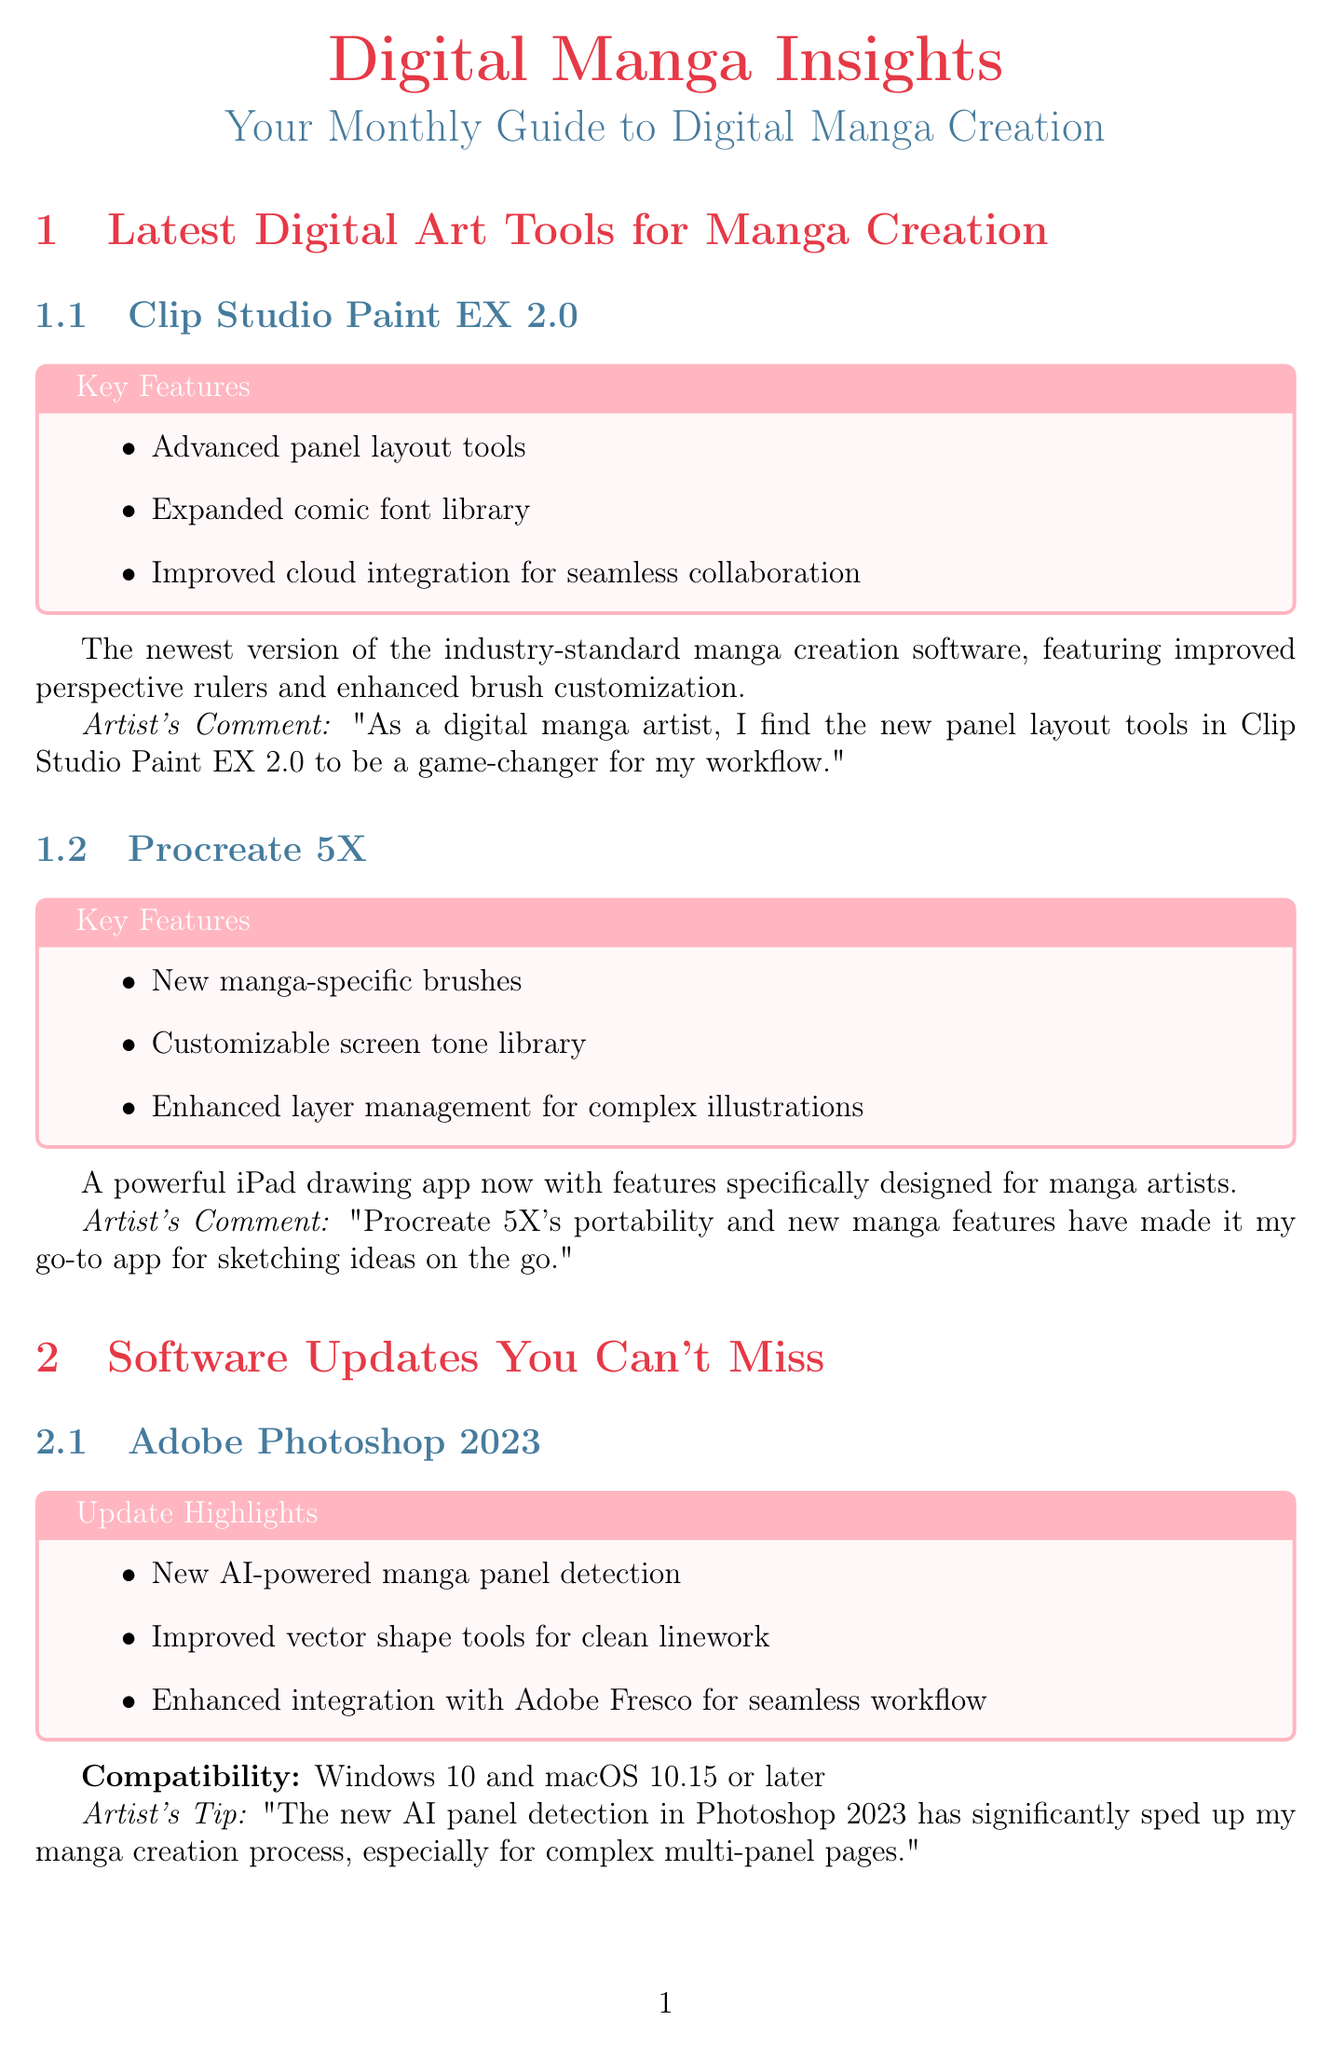What is the latest version of Clip Studio Paint? The document lists the latest version of Clip Studio Paint as EX 2.0.
Answer: EX 2.0 What new features does Procreate 5X include? Procreate 5X includes new manga-specific brushes, a customizable screen tone library, and enhanced layer management.
Answer: New manga-specific brushes, customizable screen tone library, enhanced layer management Which software has AI-powered manga panel detection? The document specifies that Adobe Photoshop 2023 has AI-powered manga panel detection.
Answer: Adobe Photoshop 2023 Who is the instructor of the tutorial on digital inking? The document identifies Satsuki Yoshino as the instructor for the tutorial on digital inking.
Answer: Satsuki Yoshino What is a new trend in digital manga creation mentioned in the newsletter? The document highlights AI-Assisted Background Generation as a new trend in digital manga creation.
Answer: AI-Assisted Background Generation How long is the tutorial on mastering digital inking? The document states that the duration of the tutorial is 1 hour 30 minutes.
Answer: 1 hour 30 minutes Which tool is suggested for creating backgrounds using AI? Midjourney for Manga Backgrounds is mentioned as an example tool for AI-assisted background generation.
Answer: Midjourney for Manga Backgrounds What software is recommended for setting up dynamic character poses? The newsletter recommends Manga Studio EX 5.0 for setting up dynamic character poses.
Answer: Manga Studio EX 5.0 What platform is the digital inking tutorial available on? The document indicates that the tutorial is available on Skillshare.
Answer: Skillshare 